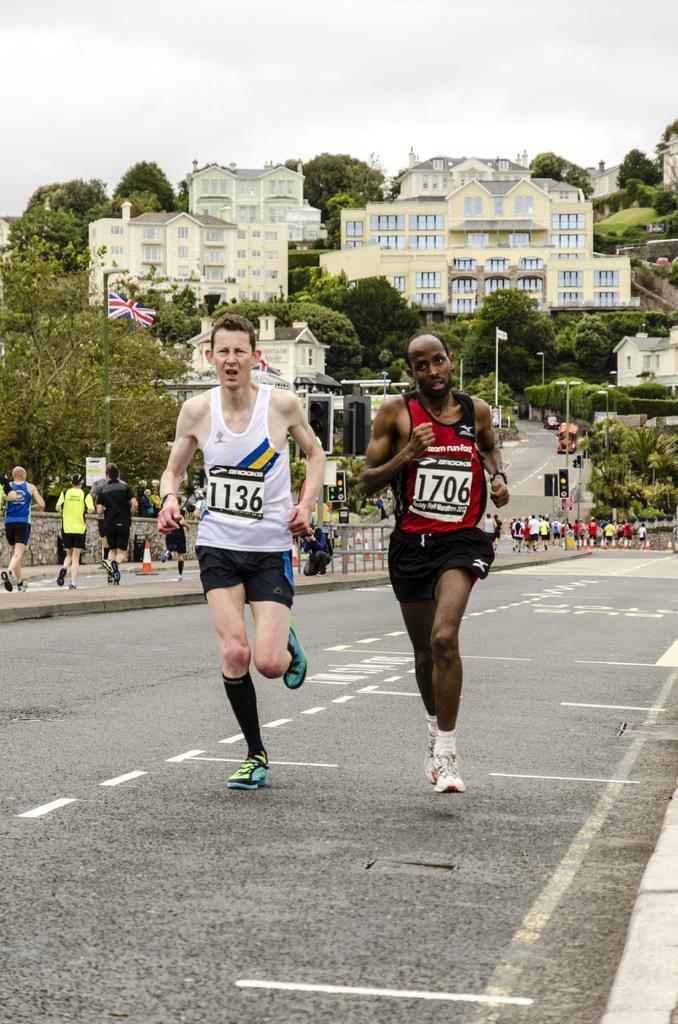In one or two sentences, can you explain what this image depicts? In the image we can see there are people running on the road and there are other people running on the footpath. Behind there are trees and there are buildings. 